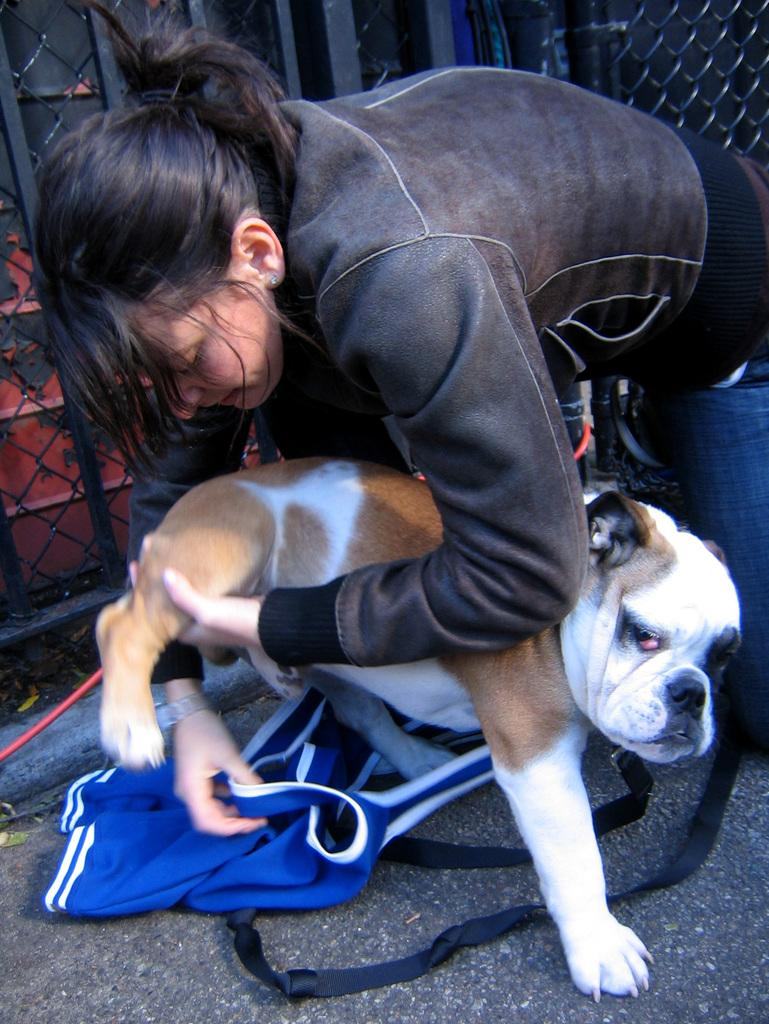What is the main subject of the image? There is a woman in the image. What is the woman doing with the dog? The woman is holding the leg of a dog and trying to wear a dress on the dog. What can be seen in the background of the image? There is a closed metal mesh fence in the background of the image. What type of curtain can be seen hanging from the dog's neck in the image? There is no curtain present in the image; the woman is trying to put a dress on the dog, not a curtain. 